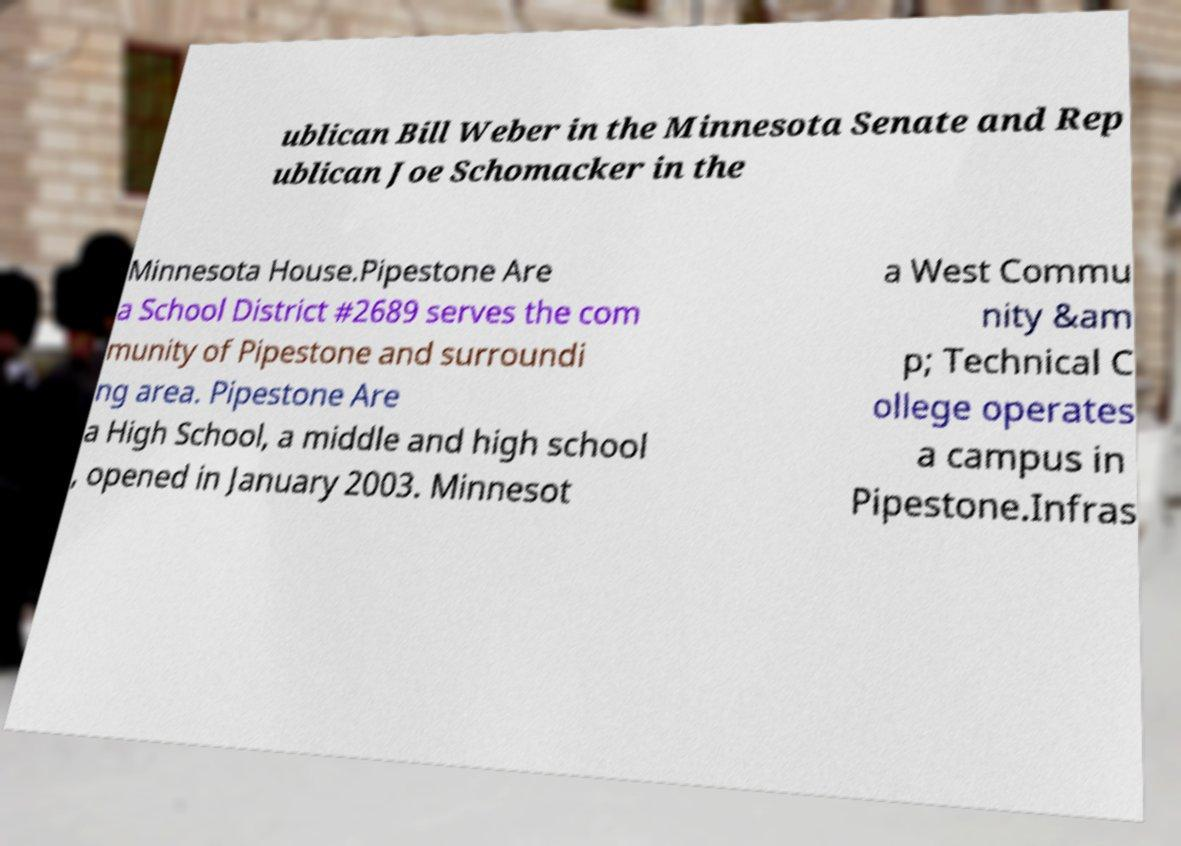There's text embedded in this image that I need extracted. Can you transcribe it verbatim? ublican Bill Weber in the Minnesota Senate and Rep ublican Joe Schomacker in the Minnesota House.Pipestone Are a School District #2689 serves the com munity of Pipestone and surroundi ng area. Pipestone Are a High School, a middle and high school , opened in January 2003. Minnesot a West Commu nity &am p; Technical C ollege operates a campus in Pipestone.Infras 